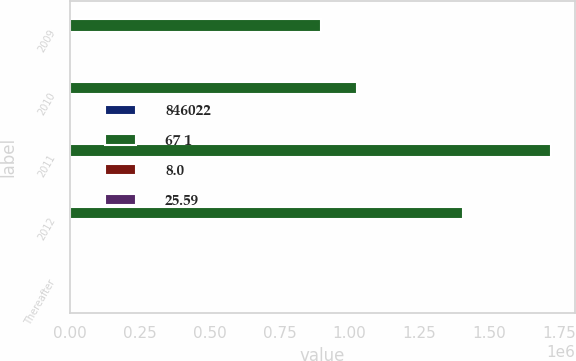<chart> <loc_0><loc_0><loc_500><loc_500><stacked_bar_chart><ecel><fcel>2009<fcel>2010<fcel>2011<fcel>2012<fcel>Thereafter<nl><fcel>846022<fcel>63<fcel>50<fcel>60<fcel>58<fcel>93<nl><fcel>67 1<fcel>896692<fcel>1.02569e+06<fcel>1.72143e+06<fcel>1.40528e+06<fcel>44<nl><fcel>8.0<fcel>8.5<fcel>9.7<fcel>16.4<fcel>13.4<fcel>44<nl><fcel>25.59<fcel>24.75<fcel>28.16<fcel>27.28<fcel>33.56<fcel>33.05<nl></chart> 